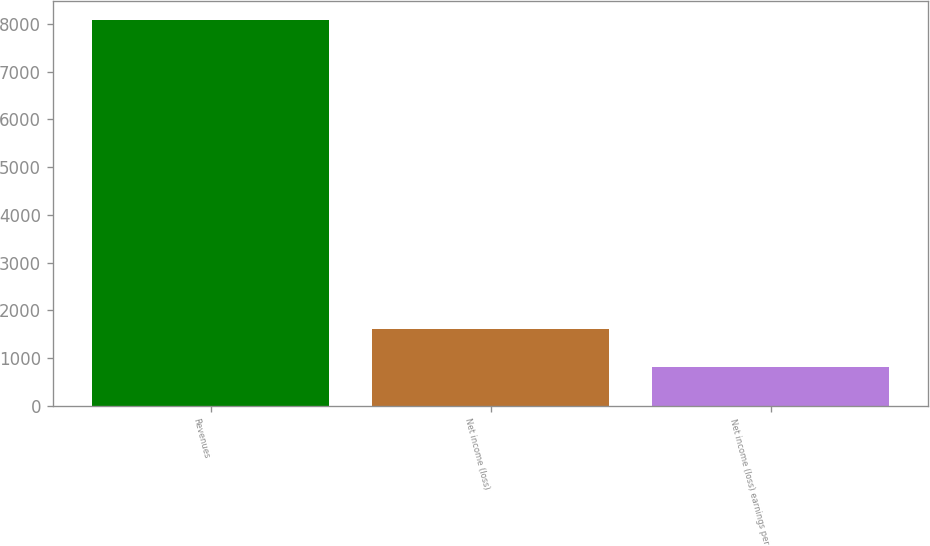Convert chart. <chart><loc_0><loc_0><loc_500><loc_500><bar_chart><fcel>Revenues<fcel>Net income (loss)<fcel>Net income (loss) earnings per<nl><fcel>8081<fcel>1617.15<fcel>809.17<nl></chart> 